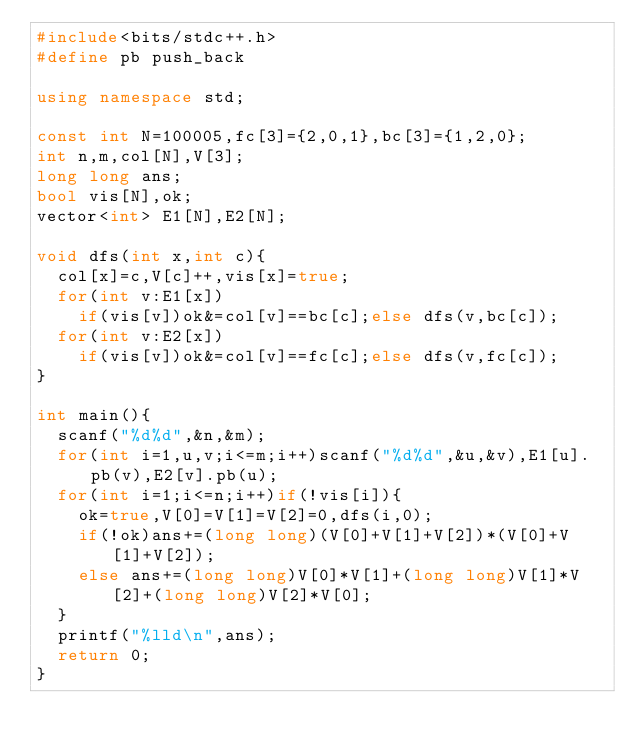<code> <loc_0><loc_0><loc_500><loc_500><_C++_>#include<bits/stdc++.h>
#define pb push_back

using namespace std;

const int N=100005,fc[3]={2,0,1},bc[3]={1,2,0};
int n,m,col[N],V[3];
long long ans;
bool vis[N],ok;
vector<int> E1[N],E2[N];

void dfs(int x,int c){
	col[x]=c,V[c]++,vis[x]=true;
	for(int v:E1[x])
		if(vis[v])ok&=col[v]==bc[c];else dfs(v,bc[c]);
	for(int v:E2[x])
		if(vis[v])ok&=col[v]==fc[c];else dfs(v,fc[c]);
}

int main(){
	scanf("%d%d",&n,&m);
	for(int i=1,u,v;i<=m;i++)scanf("%d%d",&u,&v),E1[u].pb(v),E2[v].pb(u);
	for(int i=1;i<=n;i++)if(!vis[i]){
		ok=true,V[0]=V[1]=V[2]=0,dfs(i,0);
		if(!ok)ans+=(long long)(V[0]+V[1]+V[2])*(V[0]+V[1]+V[2]);
		else ans+=(long long)V[0]*V[1]+(long long)V[1]*V[2]+(long long)V[2]*V[0];
	}
	printf("%lld\n",ans);
	return 0;
}</code> 